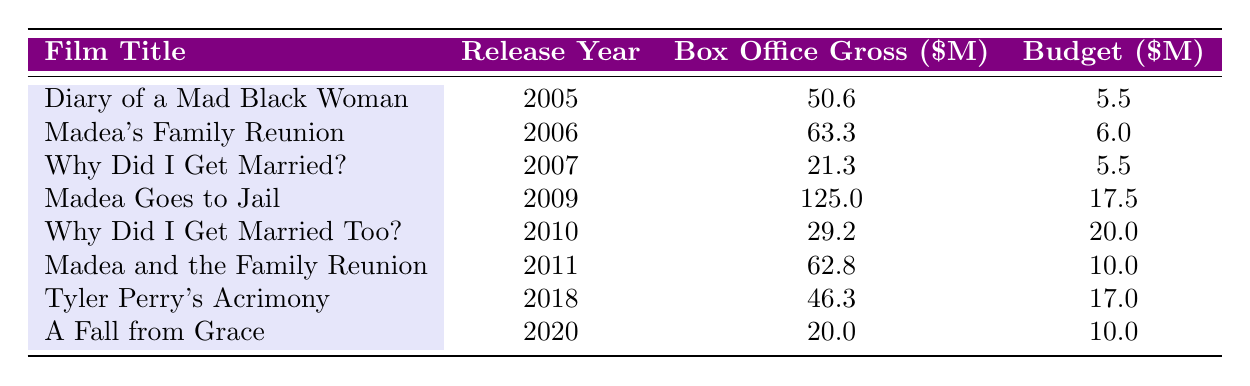What is the box office gross of "Madea Goes to Jail"? The box office gross for "Madea Goes to Jail," which was released in 2009, is listed in the table as 125.0 million dollars.
Answer: 125.0 million dollars Which film had the highest budget? Looking at the budget column, "Why Did I Get Married Too?" from 2010 has the highest budget listed at 20.0 million dollars when compared to other films.
Answer: 20.0 million dollars What is the total box office gross for Tyler Perry's films from 2005 to 2011? To find the total box office gross from 2005 to 2011, we sum the grosses: 50.6 + 63.3 + 21.3 + 125.0 + 29.2 + 62.8 = 352.2 million dollars.
Answer: 352.2 million dollars Did "Diary of a Mad Black Woman" exceed its budget in box office gross? The box office gross for "Diary of a Mad Black Woman" is 50.6 million dollars, while the budget was only 5.5 million dollars, which means it did exceed its budget.
Answer: Yes What is the average box office gross for the films released between 2006 and 2011? First, we gather the box office grosses from that timeframe: 63.3, 21.3, 125.0, 29.2, and 62.8. Adding them gives 63.3 + 21.3 + 125.0 + 29.2 + 62.8 = 301.6 million dollars. Then, we divide by the number of films (5), leading to an average of 301.6 / 5 = 60.32 million dollars.
Answer: 60.32 million dollars Which film was released in 2018? By checking the release year column, "Tyler Perry's Acrimony" is the film released in 2018.
Answer: Tyler Perry's Acrimony 